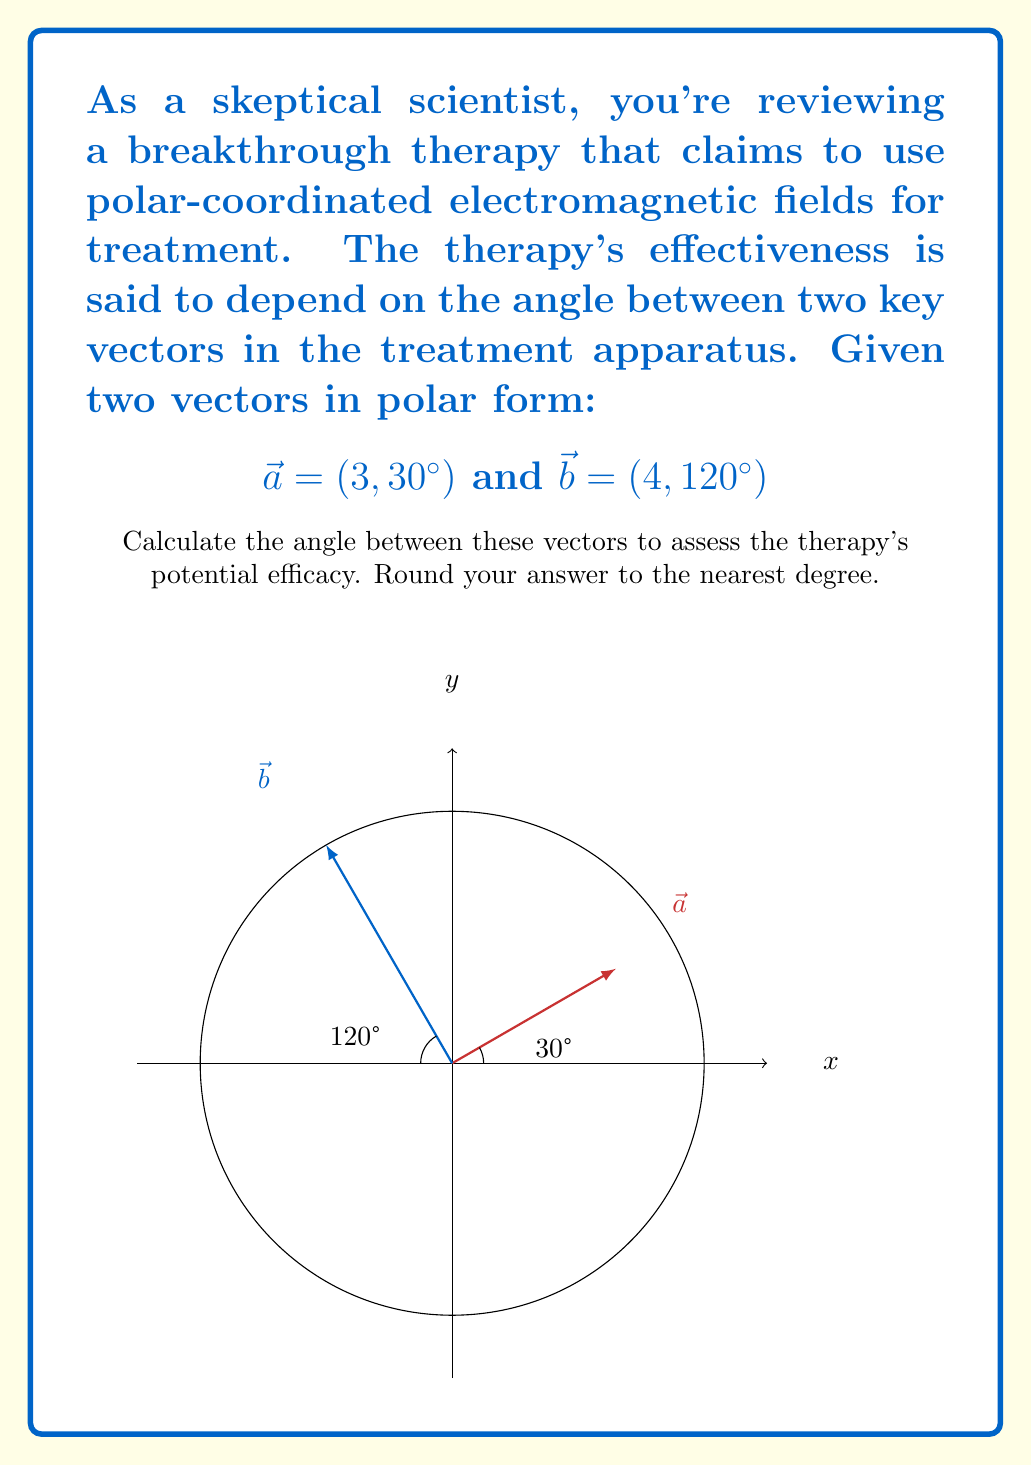Show me your answer to this math problem. To find the angle between two vectors in polar form, we can use the dot product formula:

$$\cos \theta = \frac{\vec{a} \cdot \vec{b}}{|\vec{a}||\vec{b}|}$$

1) First, we need to convert the polar coordinates to Cartesian:

   $\vec{a} = (3 \cos 30°, 3 \sin 30°)$
   $\vec{b} = (4 \cos 120°, 4 \sin 120°)$

2) Calculate the dot product $\vec{a} \cdot \vec{b}$:
   
   $\vec{a} \cdot \vec{b} = (3 \cos 30°)(4 \cos 120°) + (3 \sin 30°)(4 \sin 120°)$

3) Calculate the magnitudes:
   
   $|\vec{a}| = 3$
   $|\vec{b}| = 4$

4) Substitute into the formula:

   $$\cos \theta = \frac{(3 \cos 30°)(4 \cos 120°) + (3 \sin 30°)(4 \sin 120°)}{3 \cdot 4}$$

5) Evaluate (using a calculator):

   $$\cos \theta = -0.3660$$

6) Take the inverse cosine (arccos) of both sides:

   $$\theta = \arccos(-0.3660) \approx 111.5°$$

7) Round to the nearest degree:

   $$\theta \approx 112°$$
Answer: 112° 